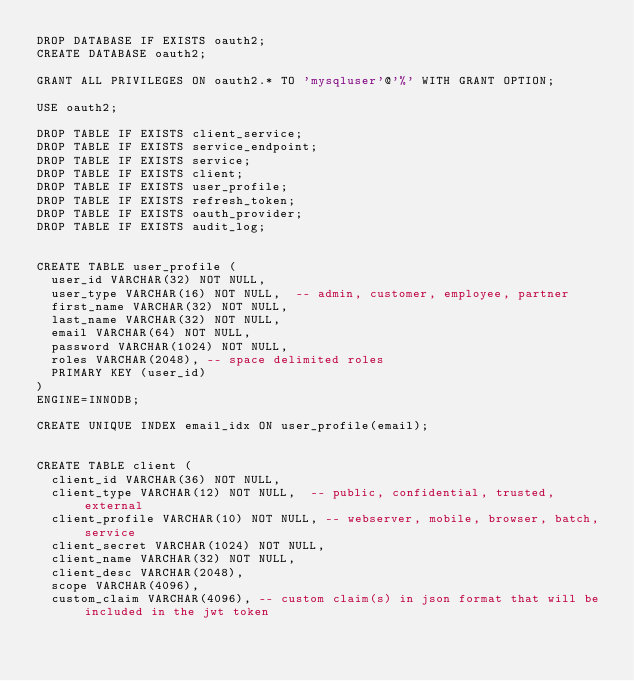Convert code to text. <code><loc_0><loc_0><loc_500><loc_500><_SQL_>DROP DATABASE IF EXISTS oauth2;
CREATE DATABASE oauth2;

GRANT ALL PRIVILEGES ON oauth2.* TO 'mysqluser'@'%' WITH GRANT OPTION;

USE oauth2;

DROP TABLE IF EXISTS client_service;
DROP TABLE IF EXISTS service_endpoint;
DROP TABLE IF EXISTS service;
DROP TABLE IF EXISTS client;
DROP TABLE IF EXISTS user_profile;
DROP TABLE IF EXISTS refresh_token;
DROP TABLE IF EXISTS oauth_provider;
DROP TABLE IF EXISTS audit_log;


CREATE TABLE user_profile (
  user_id VARCHAR(32) NOT NULL,
  user_type VARCHAR(16) NOT NULL,  -- admin, customer, employee, partner
  first_name VARCHAR(32) NOT NULL,
  last_name VARCHAR(32) NOT NULL,
  email VARCHAR(64) NOT NULL,
  password VARCHAR(1024) NOT NULL,
  roles VARCHAR(2048), -- space delimited roles
  PRIMARY KEY (user_id)
)
ENGINE=INNODB;

CREATE UNIQUE INDEX email_idx ON user_profile(email);


CREATE TABLE client (
  client_id VARCHAR(36) NOT NULL,
  client_type VARCHAR(12) NOT NULL,  -- public, confidential, trusted, external
  client_profile VARCHAR(10) NOT NULL, -- webserver, mobile, browser, batch, service
  client_secret VARCHAR(1024) NOT NULL,
  client_name VARCHAR(32) NOT NULL,
  client_desc VARCHAR(2048),
  scope VARCHAR(4096),
  custom_claim VARCHAR(4096), -- custom claim(s) in json format that will be included in the jwt token</code> 